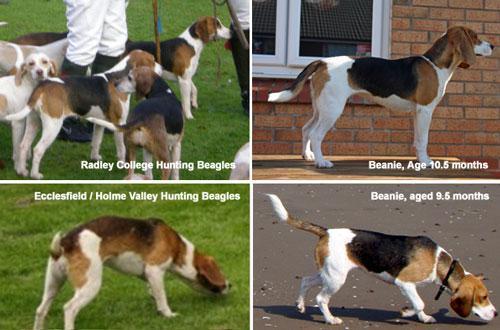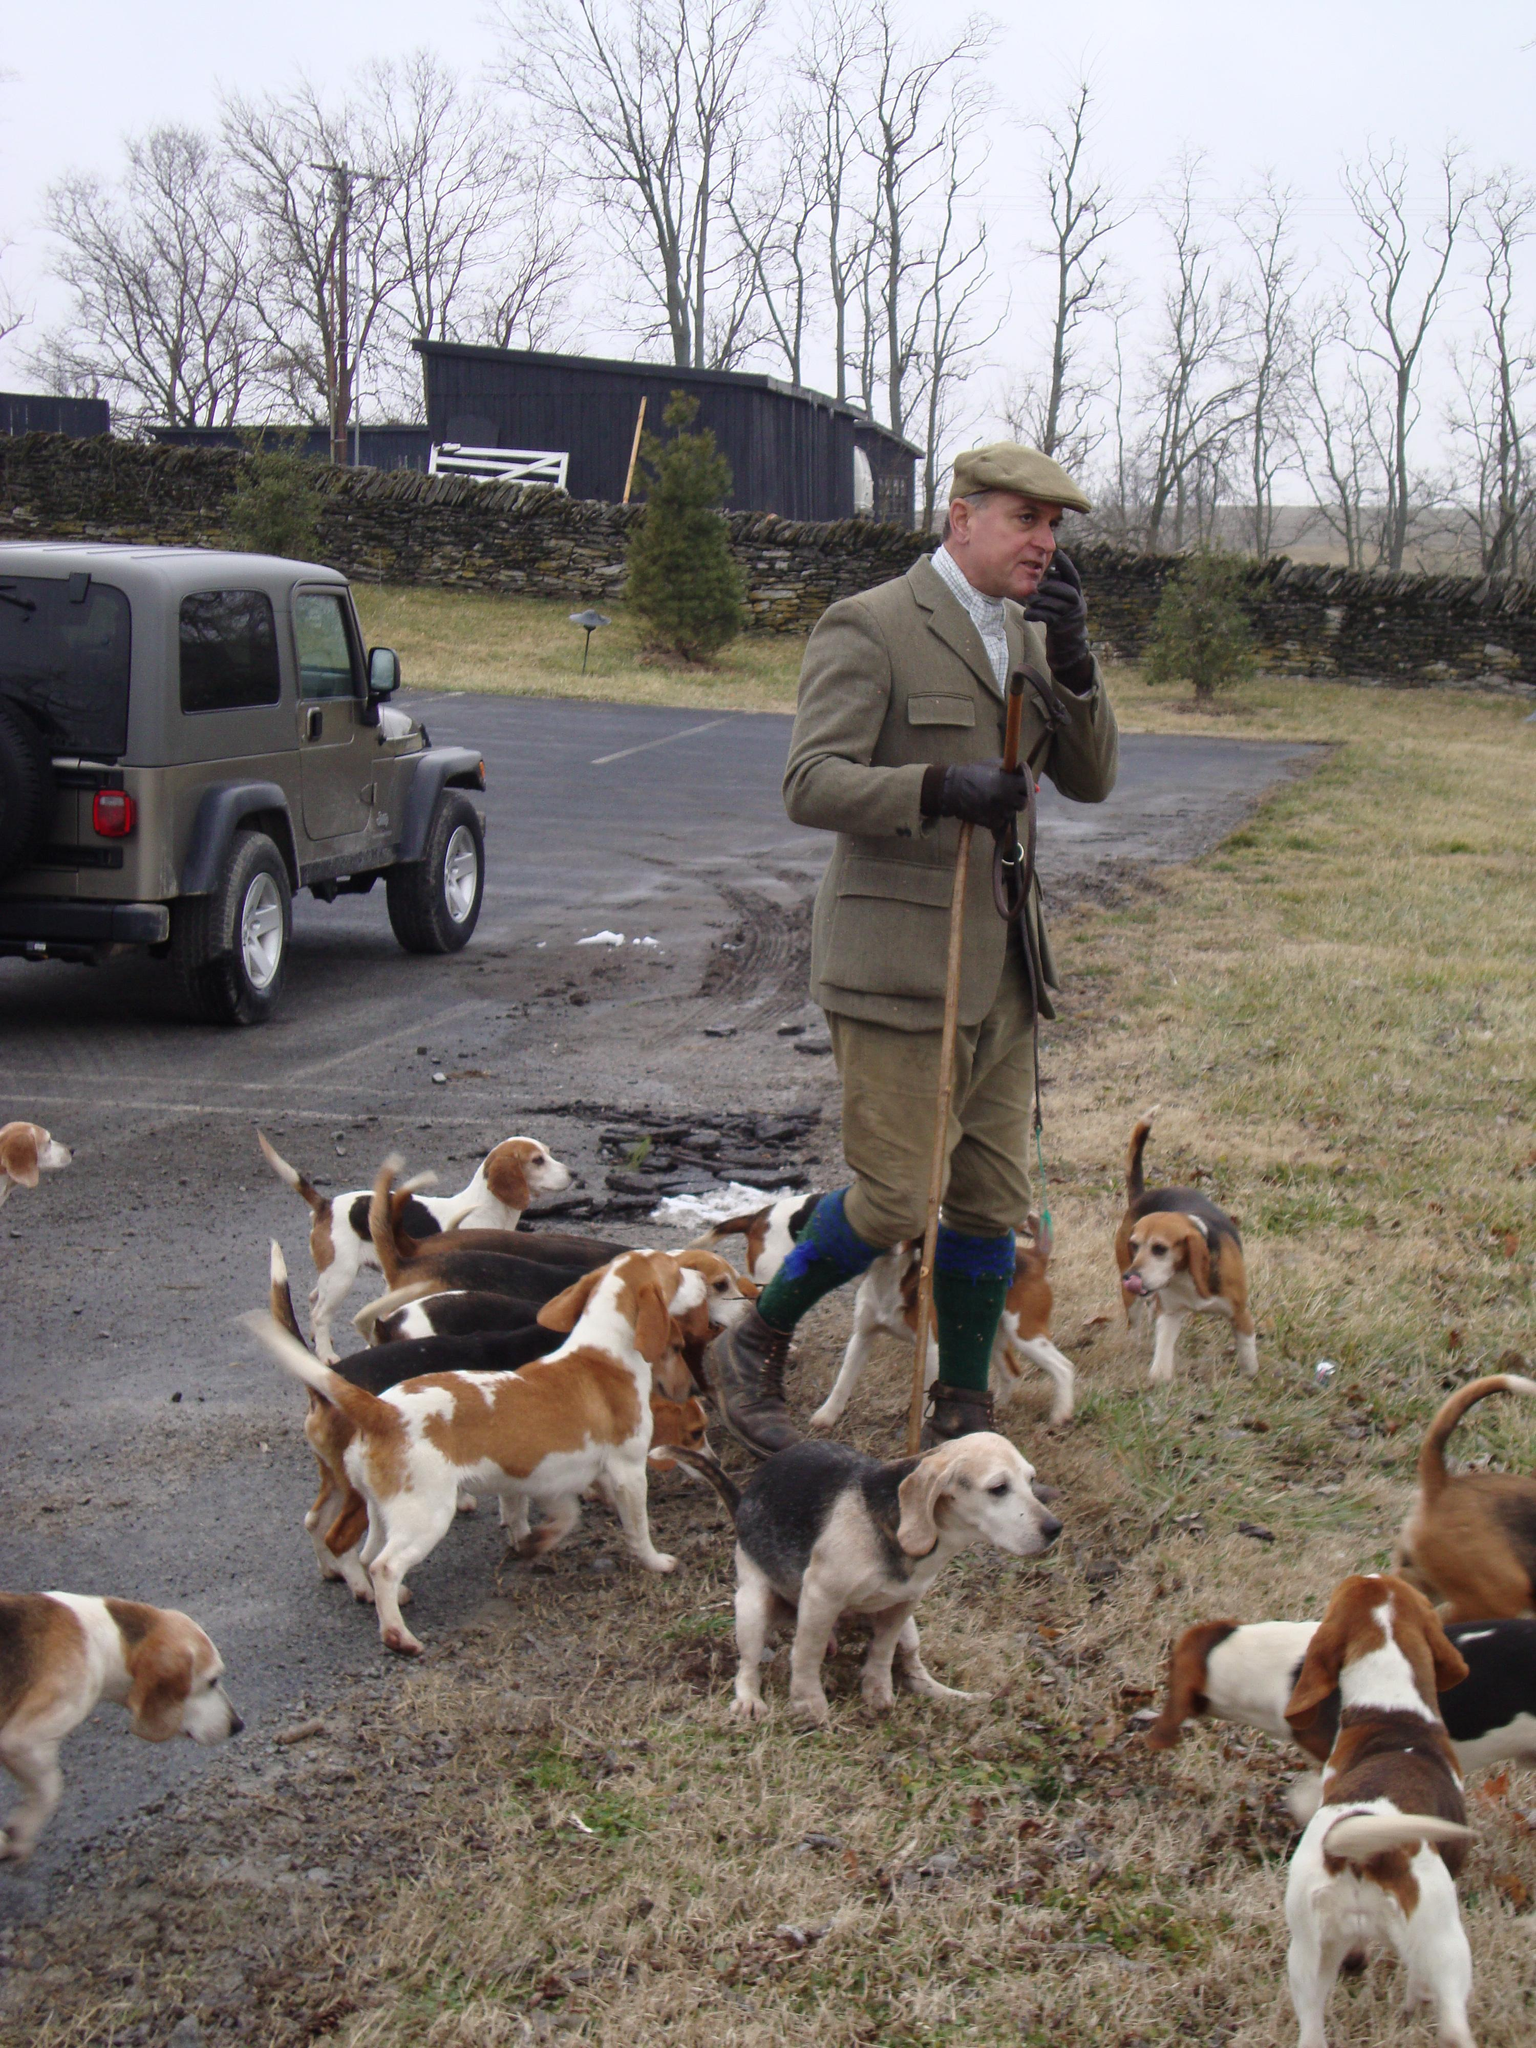The first image is the image on the left, the second image is the image on the right. Evaluate the accuracy of this statement regarding the images: "All images contain at least one man in a hat.". Is it true? Answer yes or no. No. 